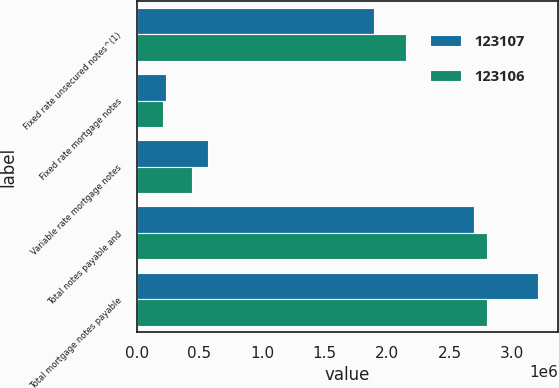Convert chart. <chart><loc_0><loc_0><loc_500><loc_500><stacked_bar_chart><ecel><fcel>Fixed rate unsecured notes^(1)<fcel>Fixed rate mortgage notes<fcel>Variable rate mortgage notes<fcel>Total notes payable and<fcel>Total mortgage notes payable<nl><fcel>123107<fcel>1.8935e+06<fcel>230050<fcel>570153<fcel>2.6937e+06<fcel>3.2082e+06<nl><fcel>123106<fcel>2.15308e+06<fcel>210114<fcel>438236<fcel>2.80143e+06<fcel>2.80143e+06<nl></chart> 